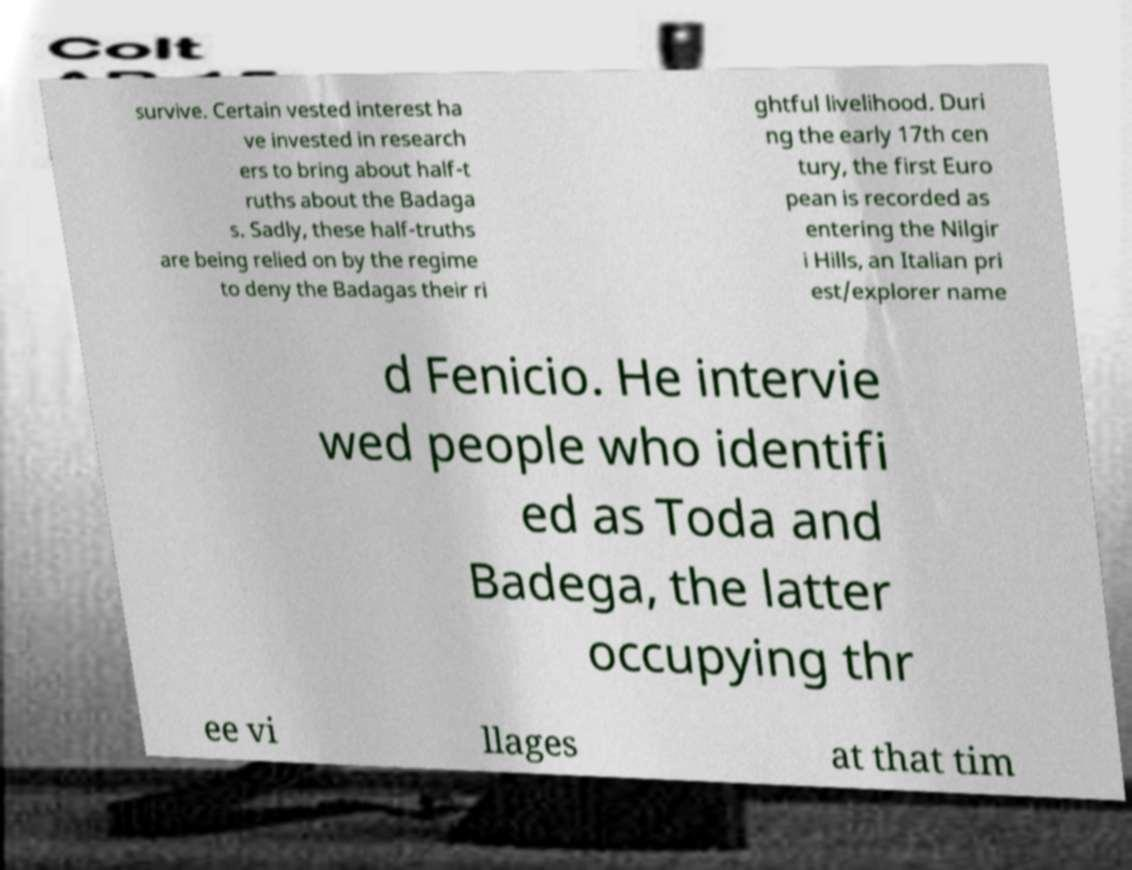For documentation purposes, I need the text within this image transcribed. Could you provide that? survive. Certain vested interest ha ve invested in research ers to bring about half-t ruths about the Badaga s. Sadly, these half-truths are being relied on by the regime to deny the Badagas their ri ghtful livelihood. Duri ng the early 17th cen tury, the first Euro pean is recorded as entering the Nilgir i Hills, an Italian pri est/explorer name d Fenicio. He intervie wed people who identifi ed as Toda and Badega, the latter occupying thr ee vi llages at that tim 